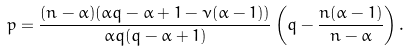<formula> <loc_0><loc_0><loc_500><loc_500>p = \frac { ( n - \alpha ) ( \alpha q - \alpha + 1 - \nu ( \alpha - 1 ) ) } { \alpha q ( q - \alpha + 1 ) } \left ( q - \frac { n ( \alpha - 1 ) } { n - \alpha } \right ) .</formula> 